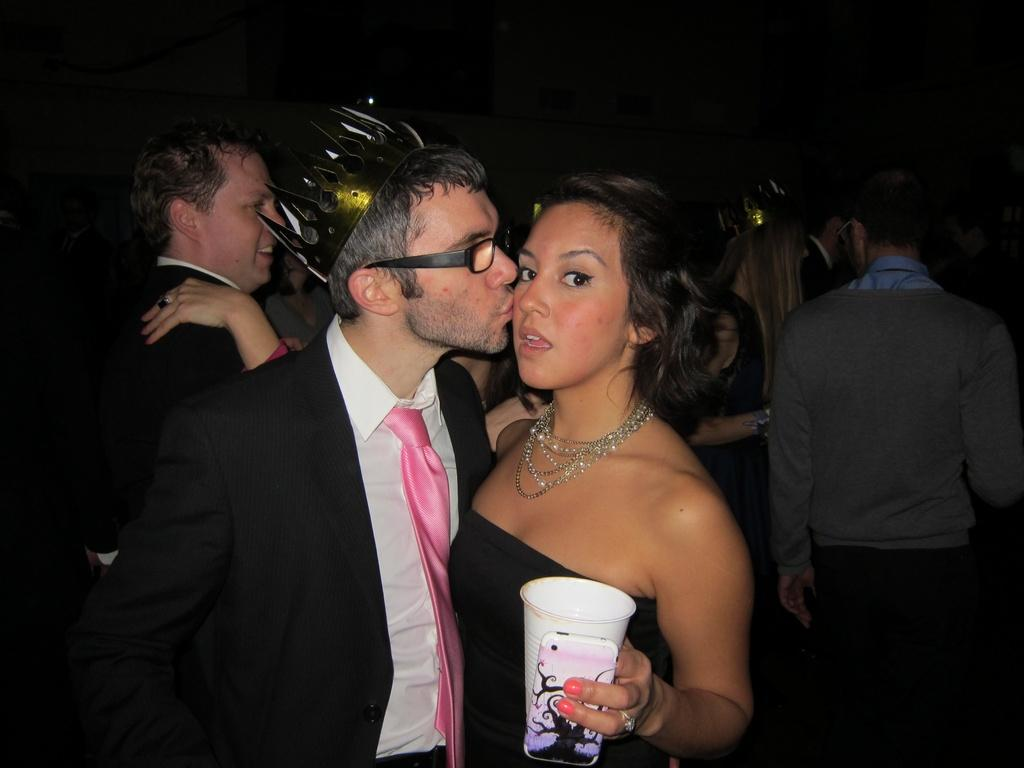How many people are in the image? There are people in the image. Can you describe any specific features of the people? Two of the people are wearing crowns. What is happening between the man and the woman in the image? The man is kissing a woman. What objects is the woman holding? The woman is holding a glass and a cell phone. What is the color of the background in the image? The background of the image is dark. What type of liquid can be seen being drawn with chalk on the wall in the image? There is no liquid or chalk present in the image, and therefore no such activity can be observed. 